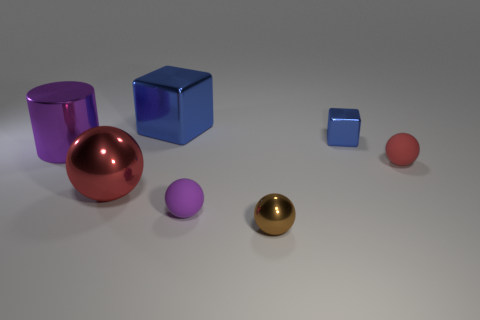What material is the purple object that is the same size as the red rubber ball?
Your response must be concise. Rubber. What size is the purple ball that is made of the same material as the small red thing?
Your response must be concise. Small. What is the material of the small red thing that is the same shape as the tiny brown metallic object?
Ensure brevity in your answer.  Rubber. There is a metal block that is in front of the big blue metal thing; does it have the same color as the metallic cube that is to the left of the small brown sphere?
Give a very brief answer. Yes. There is a large shiny object behind the purple cylinder; what is its shape?
Your response must be concise. Cube. The tiny shiny cube has what color?
Offer a very short reply. Blue. There is a tiny object that is made of the same material as the tiny blue block; what shape is it?
Your response must be concise. Sphere. Is the size of the red sphere that is behind the red metallic ball the same as the big purple cylinder?
Your answer should be compact. No. How many objects are rubber things to the right of the small blue object or tiny matte balls right of the brown shiny thing?
Offer a terse response. 1. There is a small thing that is behind the red matte ball; does it have the same color as the large metallic cube?
Make the answer very short. Yes. 